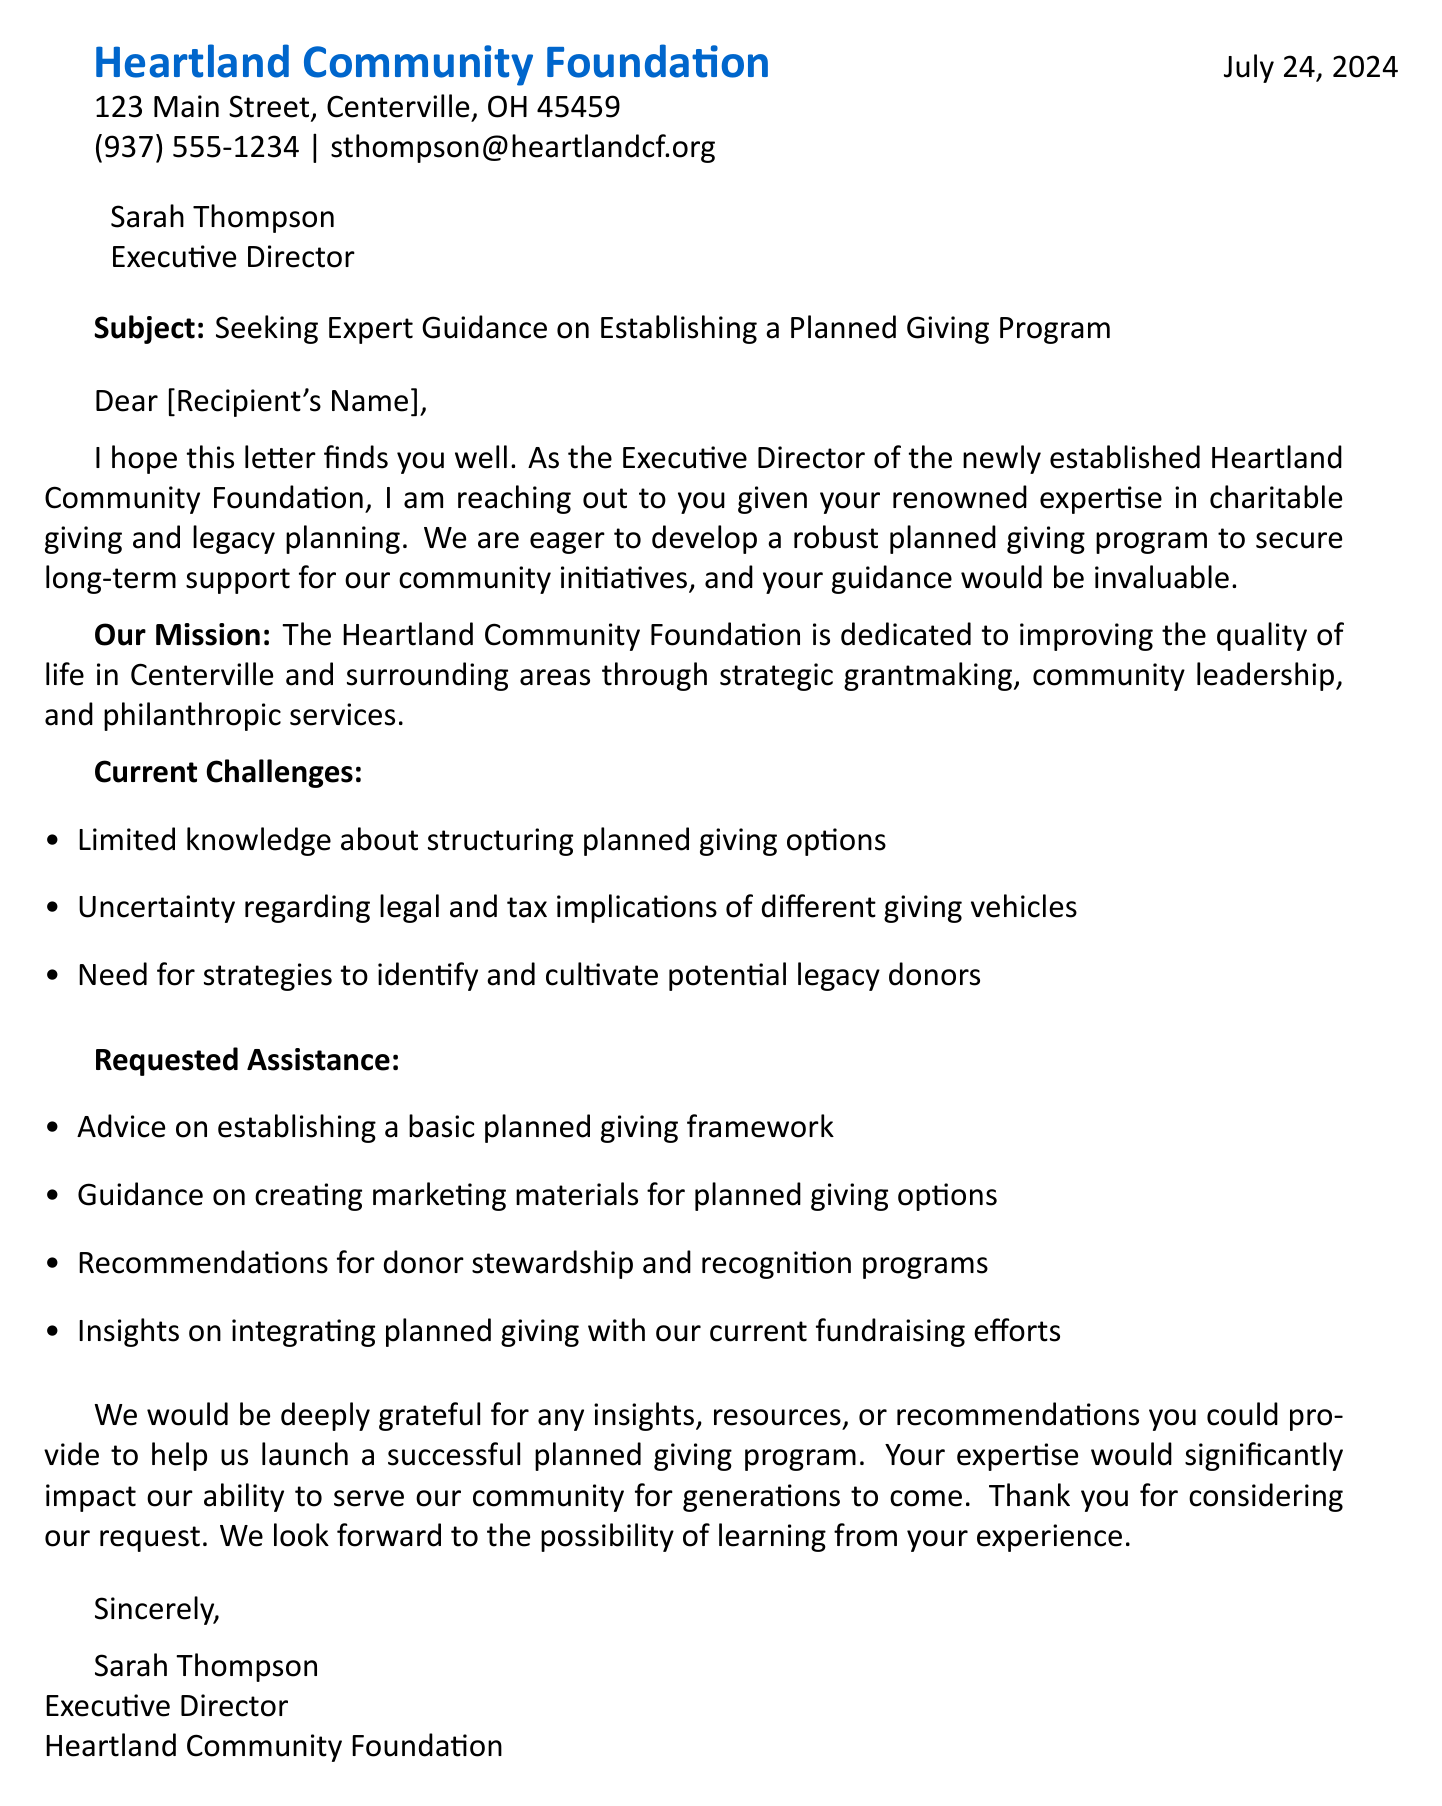What is the name of the organization? The organization name is found at the start of the document as the main subject.
Answer: Heartland Community Foundation Who is the contact person? The contact person is mentioned in the first paragraph as the individual reaching out for assistance.
Answer: Sarah Thompson What position does Sarah Thompson hold? The document specifies the role of the contact person in the header.
Answer: Executive Director What is the address of Heartland Community Foundation? The address is listed prominently at the beginning of the document.
Answer: 123 Main Street, Centerville, OH 45459 What are the current challenges faced by the organization? The challenges are outlined in a list under the section "Current Challenges."
Answer: Limited knowledge about structuring planned giving options How many requested assistance items are there? The number of items can be counted in the "Requested Assistance" section.
Answer: Four What is the main mission of Heartland Community Foundation? The mission statement is delivered in clear terms in the middle of the document.
Answer: Improving the quality of life in Centerville and surrounding areas What type of program is Heartland Community Foundation seeking to establish? The program mentioned in the opening paragraph indicates what the organization is attempting to develop.
Answer: Planned giving program What is the primary purpose of the letter? The purpose of the letter is highlighted in the introduction as the main intent of the communication.
Answer: Seeking guidance on establishing a planned giving program What kind of support is being requested from the recipient? The specifics of assistance being asked for are outlined in the "Requested Assistance" section.
Answer: Advice on establishing a basic planned giving framework 